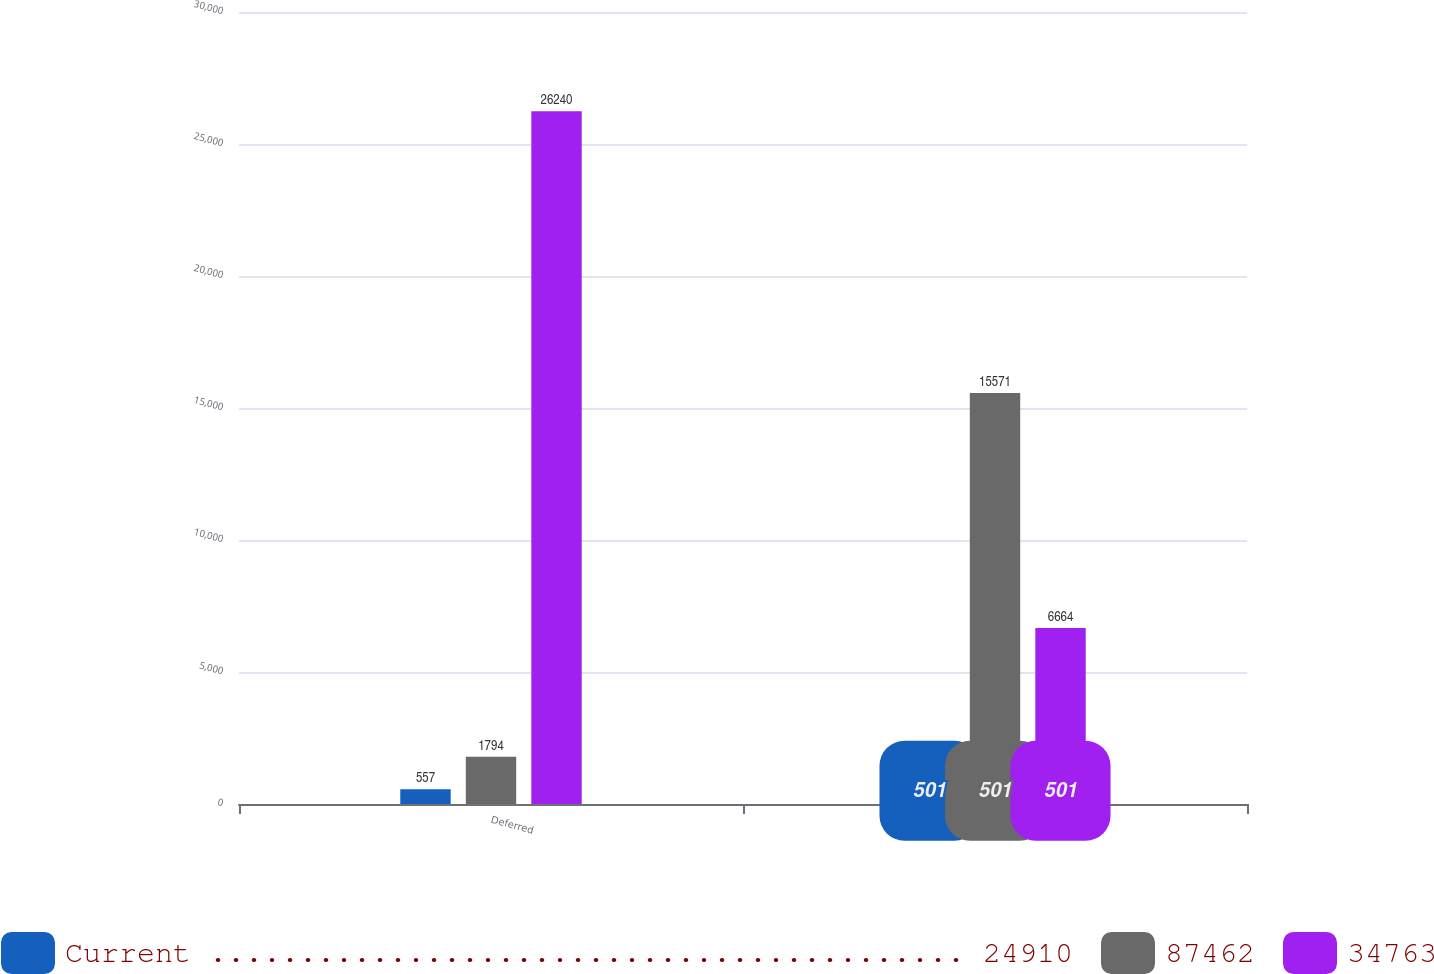Convert chart to OTSL. <chart><loc_0><loc_0><loc_500><loc_500><stacked_bar_chart><ecel><fcel>Deferred<fcel>Current<nl><fcel>Current .......................................... 24910<fcel>557<fcel>501<nl><fcel>87462<fcel>1794<fcel>15571<nl><fcel>34763<fcel>26240<fcel>6664<nl></chart> 